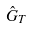<formula> <loc_0><loc_0><loc_500><loc_500>\hat { G } _ { T }</formula> 